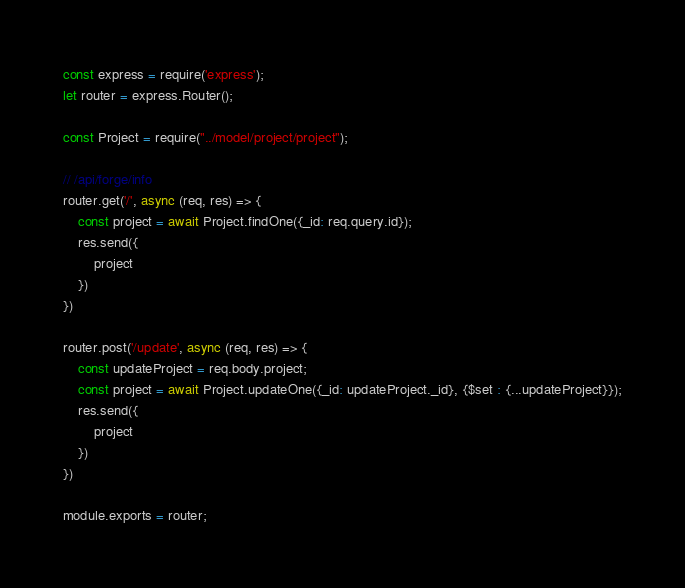Convert code to text. <code><loc_0><loc_0><loc_500><loc_500><_JavaScript_>const express = require('express');
let router = express.Router();

const Project = require("../model/project/project");

// /api/forge/info
router.get('/', async (req, res) => {
    const project = await Project.findOne({_id: req.query.id});
    res.send({
        project
    })
})

router.post('/update', async (req, res) => {
    const updateProject = req.body.project;
    const project = await Project.updateOne({_id: updateProject._id}, {$set : {...updateProject}});
    res.send({
        project
    })
})

module.exports = router;</code> 